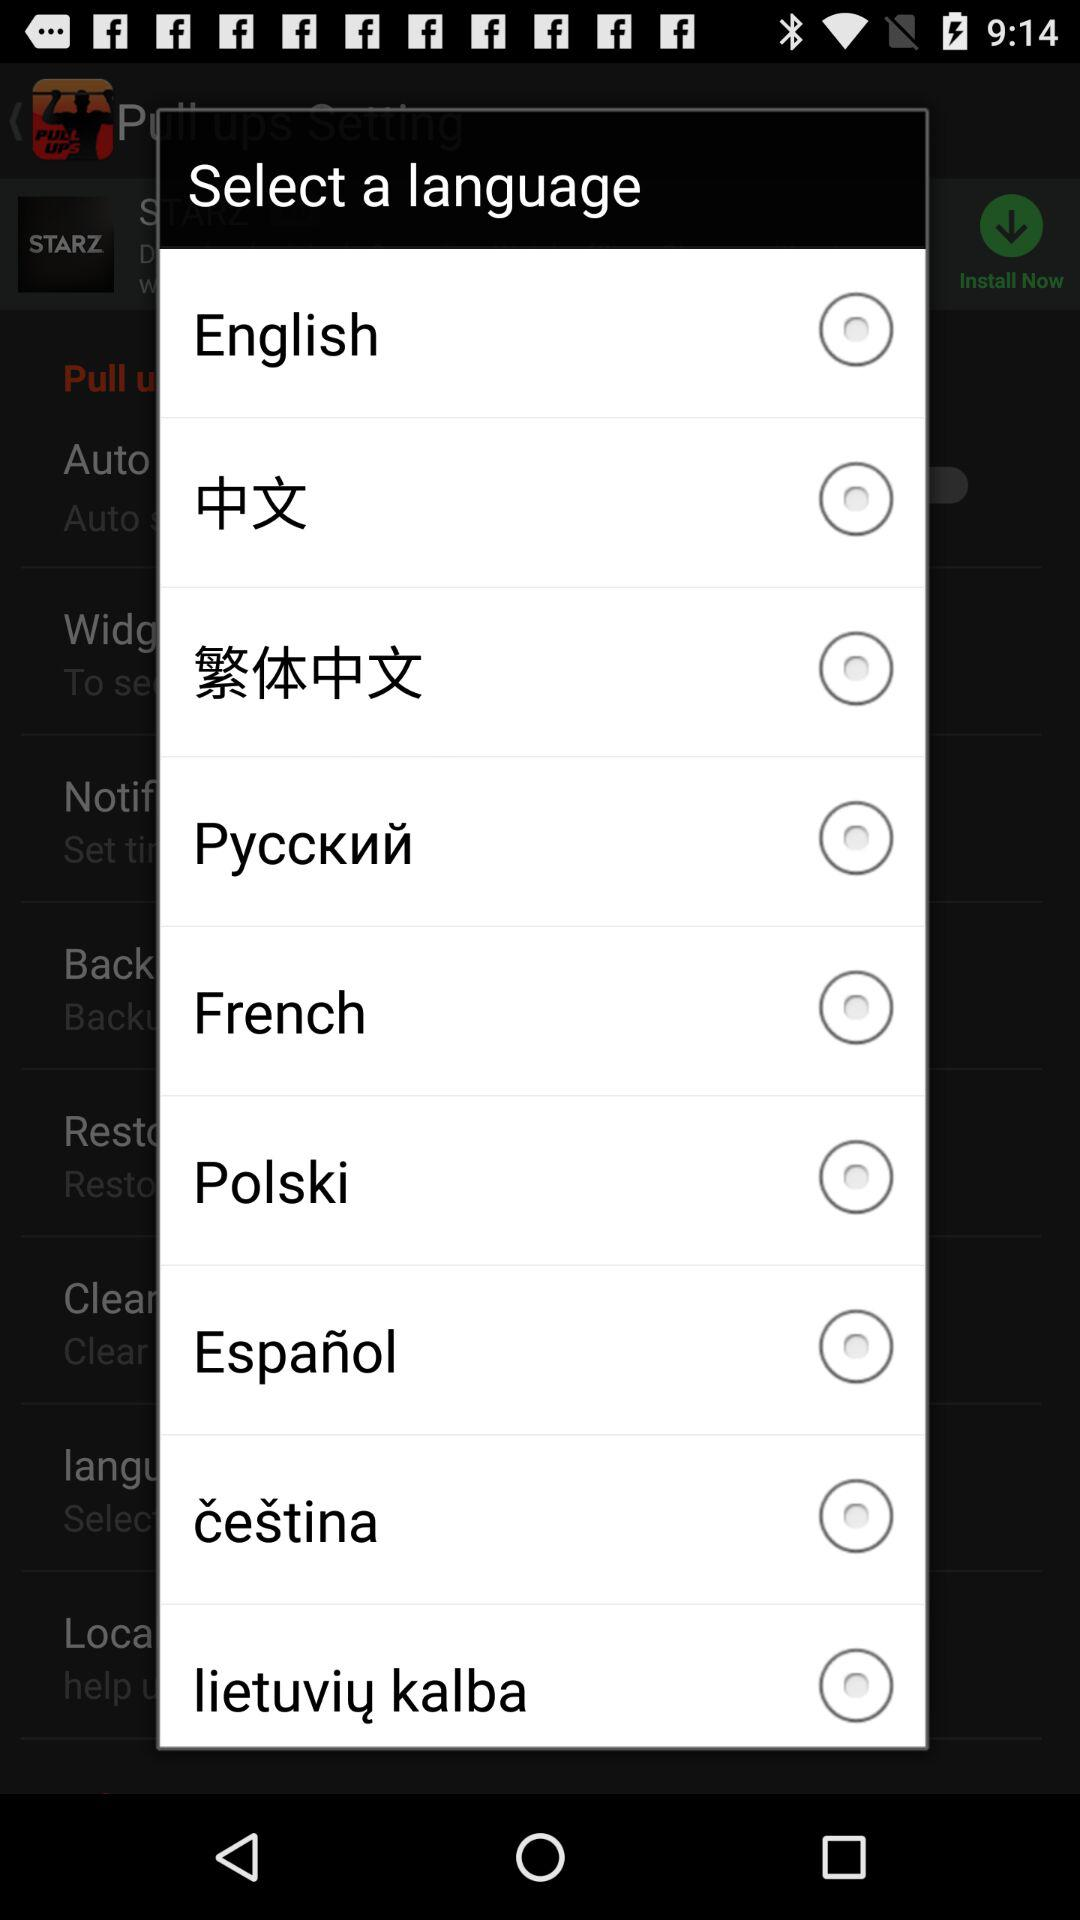What is the status of "French"? The status is "off". 